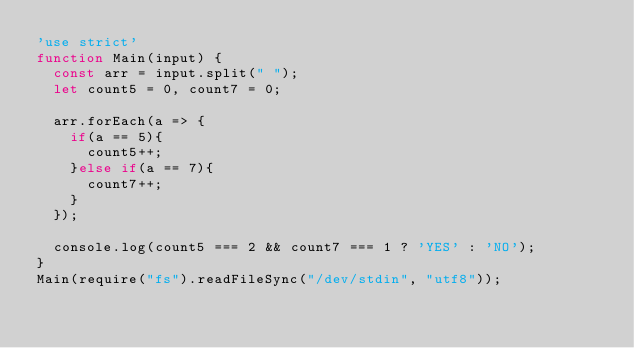Convert code to text. <code><loc_0><loc_0><loc_500><loc_500><_JavaScript_>'use strict'
function Main(input) {
  const arr = input.split(" ");
  let count5 = 0, count7 = 0;
  
  arr.forEach(a => {
    if(a == 5){
      count5++;
    }else if(a == 7){
      count7++;
    }
  });

  console.log(count5 === 2 && count7 === 1 ? 'YES' : 'NO');
}
Main(require("fs").readFileSync("/dev/stdin", "utf8"));
</code> 